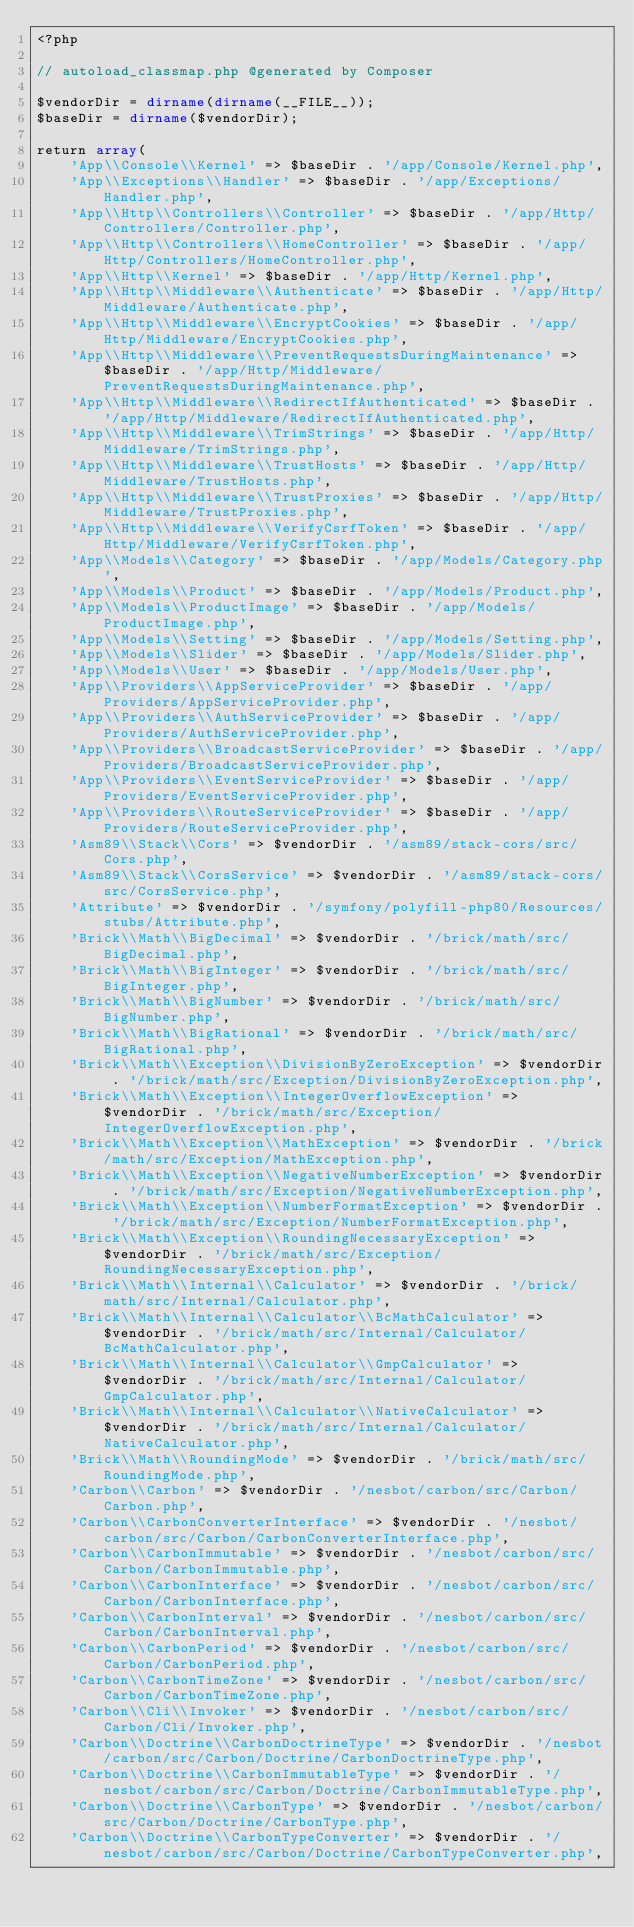<code> <loc_0><loc_0><loc_500><loc_500><_PHP_><?php

// autoload_classmap.php @generated by Composer

$vendorDir = dirname(dirname(__FILE__));
$baseDir = dirname($vendorDir);

return array(
    'App\\Console\\Kernel' => $baseDir . '/app/Console/Kernel.php',
    'App\\Exceptions\\Handler' => $baseDir . '/app/Exceptions/Handler.php',
    'App\\Http\\Controllers\\Controller' => $baseDir . '/app/Http/Controllers/Controller.php',
    'App\\Http\\Controllers\\HomeController' => $baseDir . '/app/Http/Controllers/HomeController.php',
    'App\\Http\\Kernel' => $baseDir . '/app/Http/Kernel.php',
    'App\\Http\\Middleware\\Authenticate' => $baseDir . '/app/Http/Middleware/Authenticate.php',
    'App\\Http\\Middleware\\EncryptCookies' => $baseDir . '/app/Http/Middleware/EncryptCookies.php',
    'App\\Http\\Middleware\\PreventRequestsDuringMaintenance' => $baseDir . '/app/Http/Middleware/PreventRequestsDuringMaintenance.php',
    'App\\Http\\Middleware\\RedirectIfAuthenticated' => $baseDir . '/app/Http/Middleware/RedirectIfAuthenticated.php',
    'App\\Http\\Middleware\\TrimStrings' => $baseDir . '/app/Http/Middleware/TrimStrings.php',
    'App\\Http\\Middleware\\TrustHosts' => $baseDir . '/app/Http/Middleware/TrustHosts.php',
    'App\\Http\\Middleware\\TrustProxies' => $baseDir . '/app/Http/Middleware/TrustProxies.php',
    'App\\Http\\Middleware\\VerifyCsrfToken' => $baseDir . '/app/Http/Middleware/VerifyCsrfToken.php',
    'App\\Models\\Category' => $baseDir . '/app/Models/Category.php',
    'App\\Models\\Product' => $baseDir . '/app/Models/Product.php',
    'App\\Models\\ProductImage' => $baseDir . '/app/Models/ProductImage.php',
    'App\\Models\\Setting' => $baseDir . '/app/Models/Setting.php',
    'App\\Models\\Slider' => $baseDir . '/app/Models/Slider.php',
    'App\\Models\\User' => $baseDir . '/app/Models/User.php',
    'App\\Providers\\AppServiceProvider' => $baseDir . '/app/Providers/AppServiceProvider.php',
    'App\\Providers\\AuthServiceProvider' => $baseDir . '/app/Providers/AuthServiceProvider.php',
    'App\\Providers\\BroadcastServiceProvider' => $baseDir . '/app/Providers/BroadcastServiceProvider.php',
    'App\\Providers\\EventServiceProvider' => $baseDir . '/app/Providers/EventServiceProvider.php',
    'App\\Providers\\RouteServiceProvider' => $baseDir . '/app/Providers/RouteServiceProvider.php',
    'Asm89\\Stack\\Cors' => $vendorDir . '/asm89/stack-cors/src/Cors.php',
    'Asm89\\Stack\\CorsService' => $vendorDir . '/asm89/stack-cors/src/CorsService.php',
    'Attribute' => $vendorDir . '/symfony/polyfill-php80/Resources/stubs/Attribute.php',
    'Brick\\Math\\BigDecimal' => $vendorDir . '/brick/math/src/BigDecimal.php',
    'Brick\\Math\\BigInteger' => $vendorDir . '/brick/math/src/BigInteger.php',
    'Brick\\Math\\BigNumber' => $vendorDir . '/brick/math/src/BigNumber.php',
    'Brick\\Math\\BigRational' => $vendorDir . '/brick/math/src/BigRational.php',
    'Brick\\Math\\Exception\\DivisionByZeroException' => $vendorDir . '/brick/math/src/Exception/DivisionByZeroException.php',
    'Brick\\Math\\Exception\\IntegerOverflowException' => $vendorDir . '/brick/math/src/Exception/IntegerOverflowException.php',
    'Brick\\Math\\Exception\\MathException' => $vendorDir . '/brick/math/src/Exception/MathException.php',
    'Brick\\Math\\Exception\\NegativeNumberException' => $vendorDir . '/brick/math/src/Exception/NegativeNumberException.php',
    'Brick\\Math\\Exception\\NumberFormatException' => $vendorDir . '/brick/math/src/Exception/NumberFormatException.php',
    'Brick\\Math\\Exception\\RoundingNecessaryException' => $vendorDir . '/brick/math/src/Exception/RoundingNecessaryException.php',
    'Brick\\Math\\Internal\\Calculator' => $vendorDir . '/brick/math/src/Internal/Calculator.php',
    'Brick\\Math\\Internal\\Calculator\\BcMathCalculator' => $vendorDir . '/brick/math/src/Internal/Calculator/BcMathCalculator.php',
    'Brick\\Math\\Internal\\Calculator\\GmpCalculator' => $vendorDir . '/brick/math/src/Internal/Calculator/GmpCalculator.php',
    'Brick\\Math\\Internal\\Calculator\\NativeCalculator' => $vendorDir . '/brick/math/src/Internal/Calculator/NativeCalculator.php',
    'Brick\\Math\\RoundingMode' => $vendorDir . '/brick/math/src/RoundingMode.php',
    'Carbon\\Carbon' => $vendorDir . '/nesbot/carbon/src/Carbon/Carbon.php',
    'Carbon\\CarbonConverterInterface' => $vendorDir . '/nesbot/carbon/src/Carbon/CarbonConverterInterface.php',
    'Carbon\\CarbonImmutable' => $vendorDir . '/nesbot/carbon/src/Carbon/CarbonImmutable.php',
    'Carbon\\CarbonInterface' => $vendorDir . '/nesbot/carbon/src/Carbon/CarbonInterface.php',
    'Carbon\\CarbonInterval' => $vendorDir . '/nesbot/carbon/src/Carbon/CarbonInterval.php',
    'Carbon\\CarbonPeriod' => $vendorDir . '/nesbot/carbon/src/Carbon/CarbonPeriod.php',
    'Carbon\\CarbonTimeZone' => $vendorDir . '/nesbot/carbon/src/Carbon/CarbonTimeZone.php',
    'Carbon\\Cli\\Invoker' => $vendorDir . '/nesbot/carbon/src/Carbon/Cli/Invoker.php',
    'Carbon\\Doctrine\\CarbonDoctrineType' => $vendorDir . '/nesbot/carbon/src/Carbon/Doctrine/CarbonDoctrineType.php',
    'Carbon\\Doctrine\\CarbonImmutableType' => $vendorDir . '/nesbot/carbon/src/Carbon/Doctrine/CarbonImmutableType.php',
    'Carbon\\Doctrine\\CarbonType' => $vendorDir . '/nesbot/carbon/src/Carbon/Doctrine/CarbonType.php',
    'Carbon\\Doctrine\\CarbonTypeConverter' => $vendorDir . '/nesbot/carbon/src/Carbon/Doctrine/CarbonTypeConverter.php',</code> 